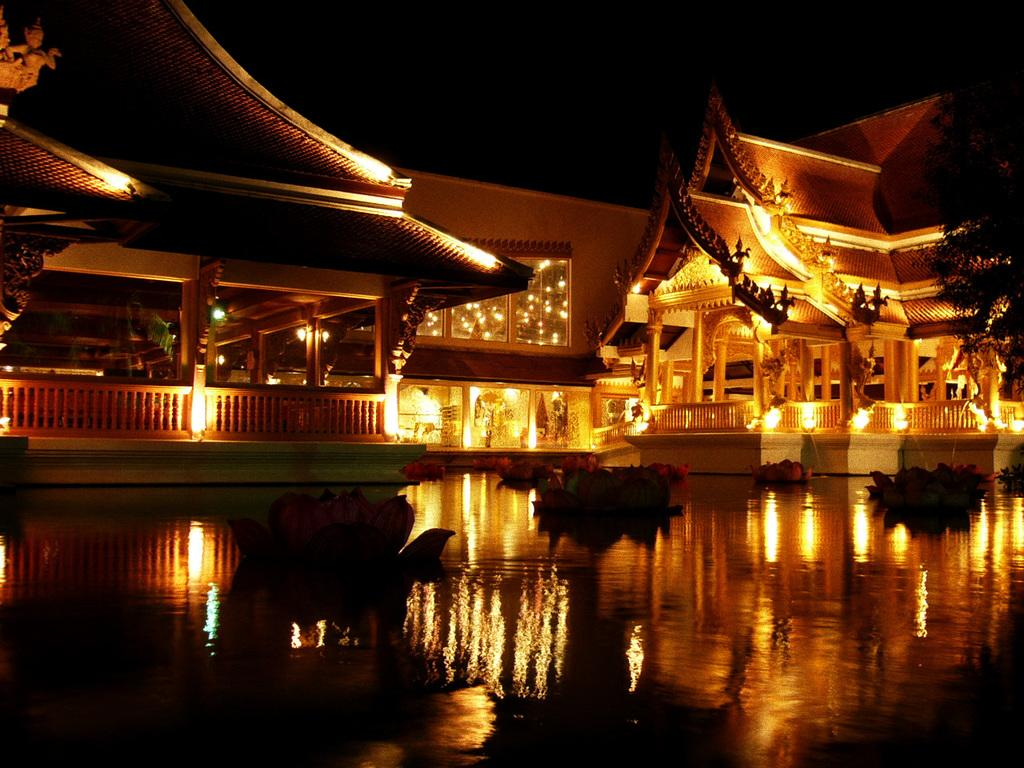What is floating on the water in the image? There are flowers on the water in the image. What type of structures can be seen in the image? There are buildings in the image. What artistic elements are present in the image? There are sculptures in the image. What can be seen illuminating the scene in the image? There are lights in the image. How would you describe the overall lighting in the image? The background of the image is dark. What type of hair can be seen on the sculptures in the image? There is no hair present on the sculptures in the image. How many sticks are visible in the image? There are no sticks visible in the image. 